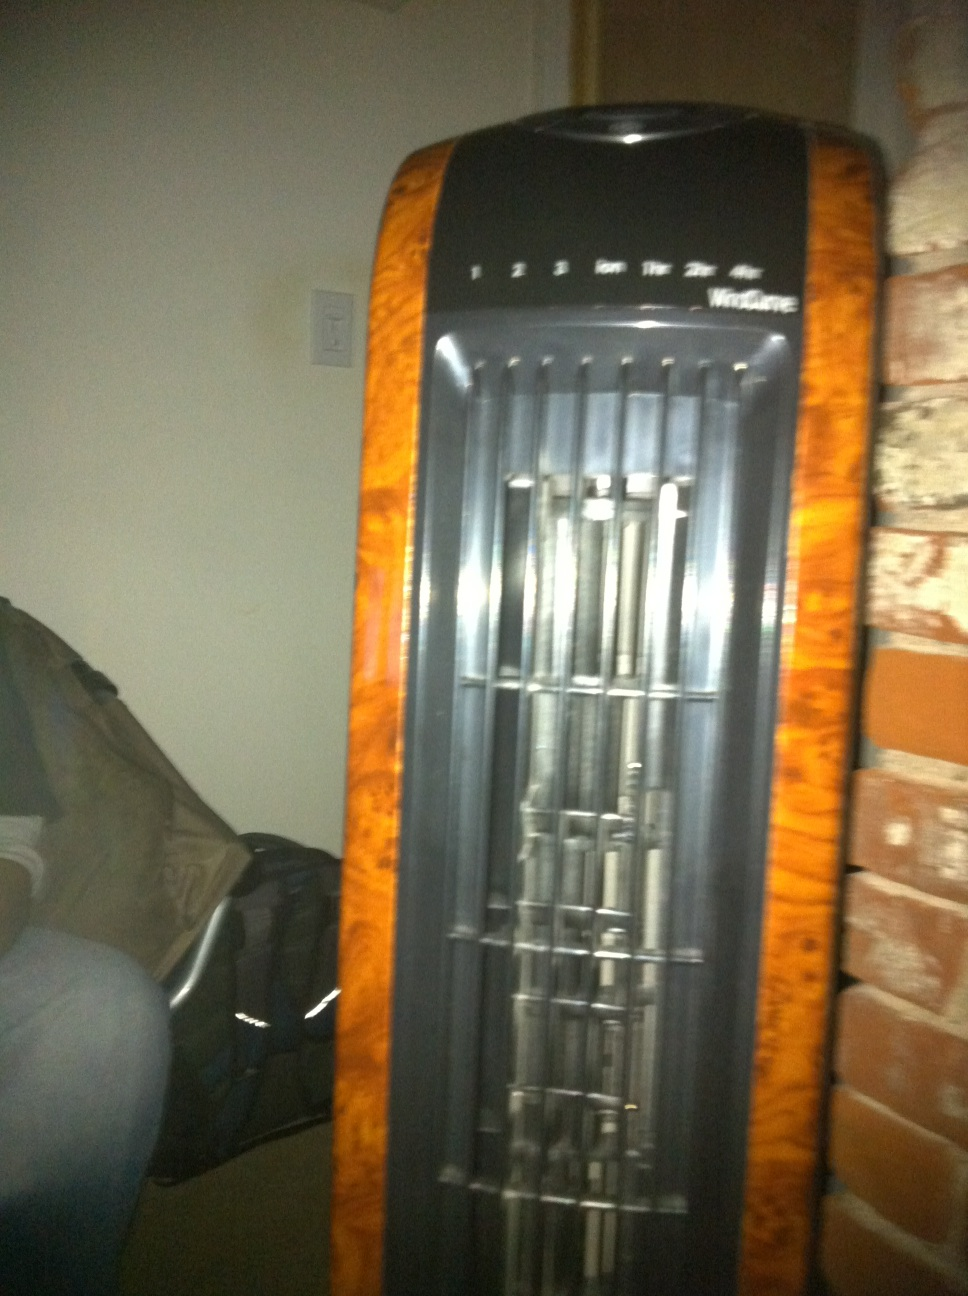Imagine the fan is an intergalactic device. What does it do? Imagine this fan as an advanced intergalactic device! It doesn't just cool the air; it purifies and energizes it with cosmic particles. This device can also generate a small force field, making it an invaluable tool for space travelers seeking comfort and protection in the harsh environments of distant planets. 